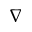<formula> <loc_0><loc_0><loc_500><loc_500>\nabla</formula> 